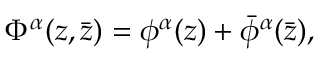<formula> <loc_0><loc_0><loc_500><loc_500>\Phi ^ { \alpha } ( z , \bar { z } ) = \phi ^ { \alpha } ( z ) + \bar { \phi } ^ { \alpha } ( \bar { z } ) ,</formula> 